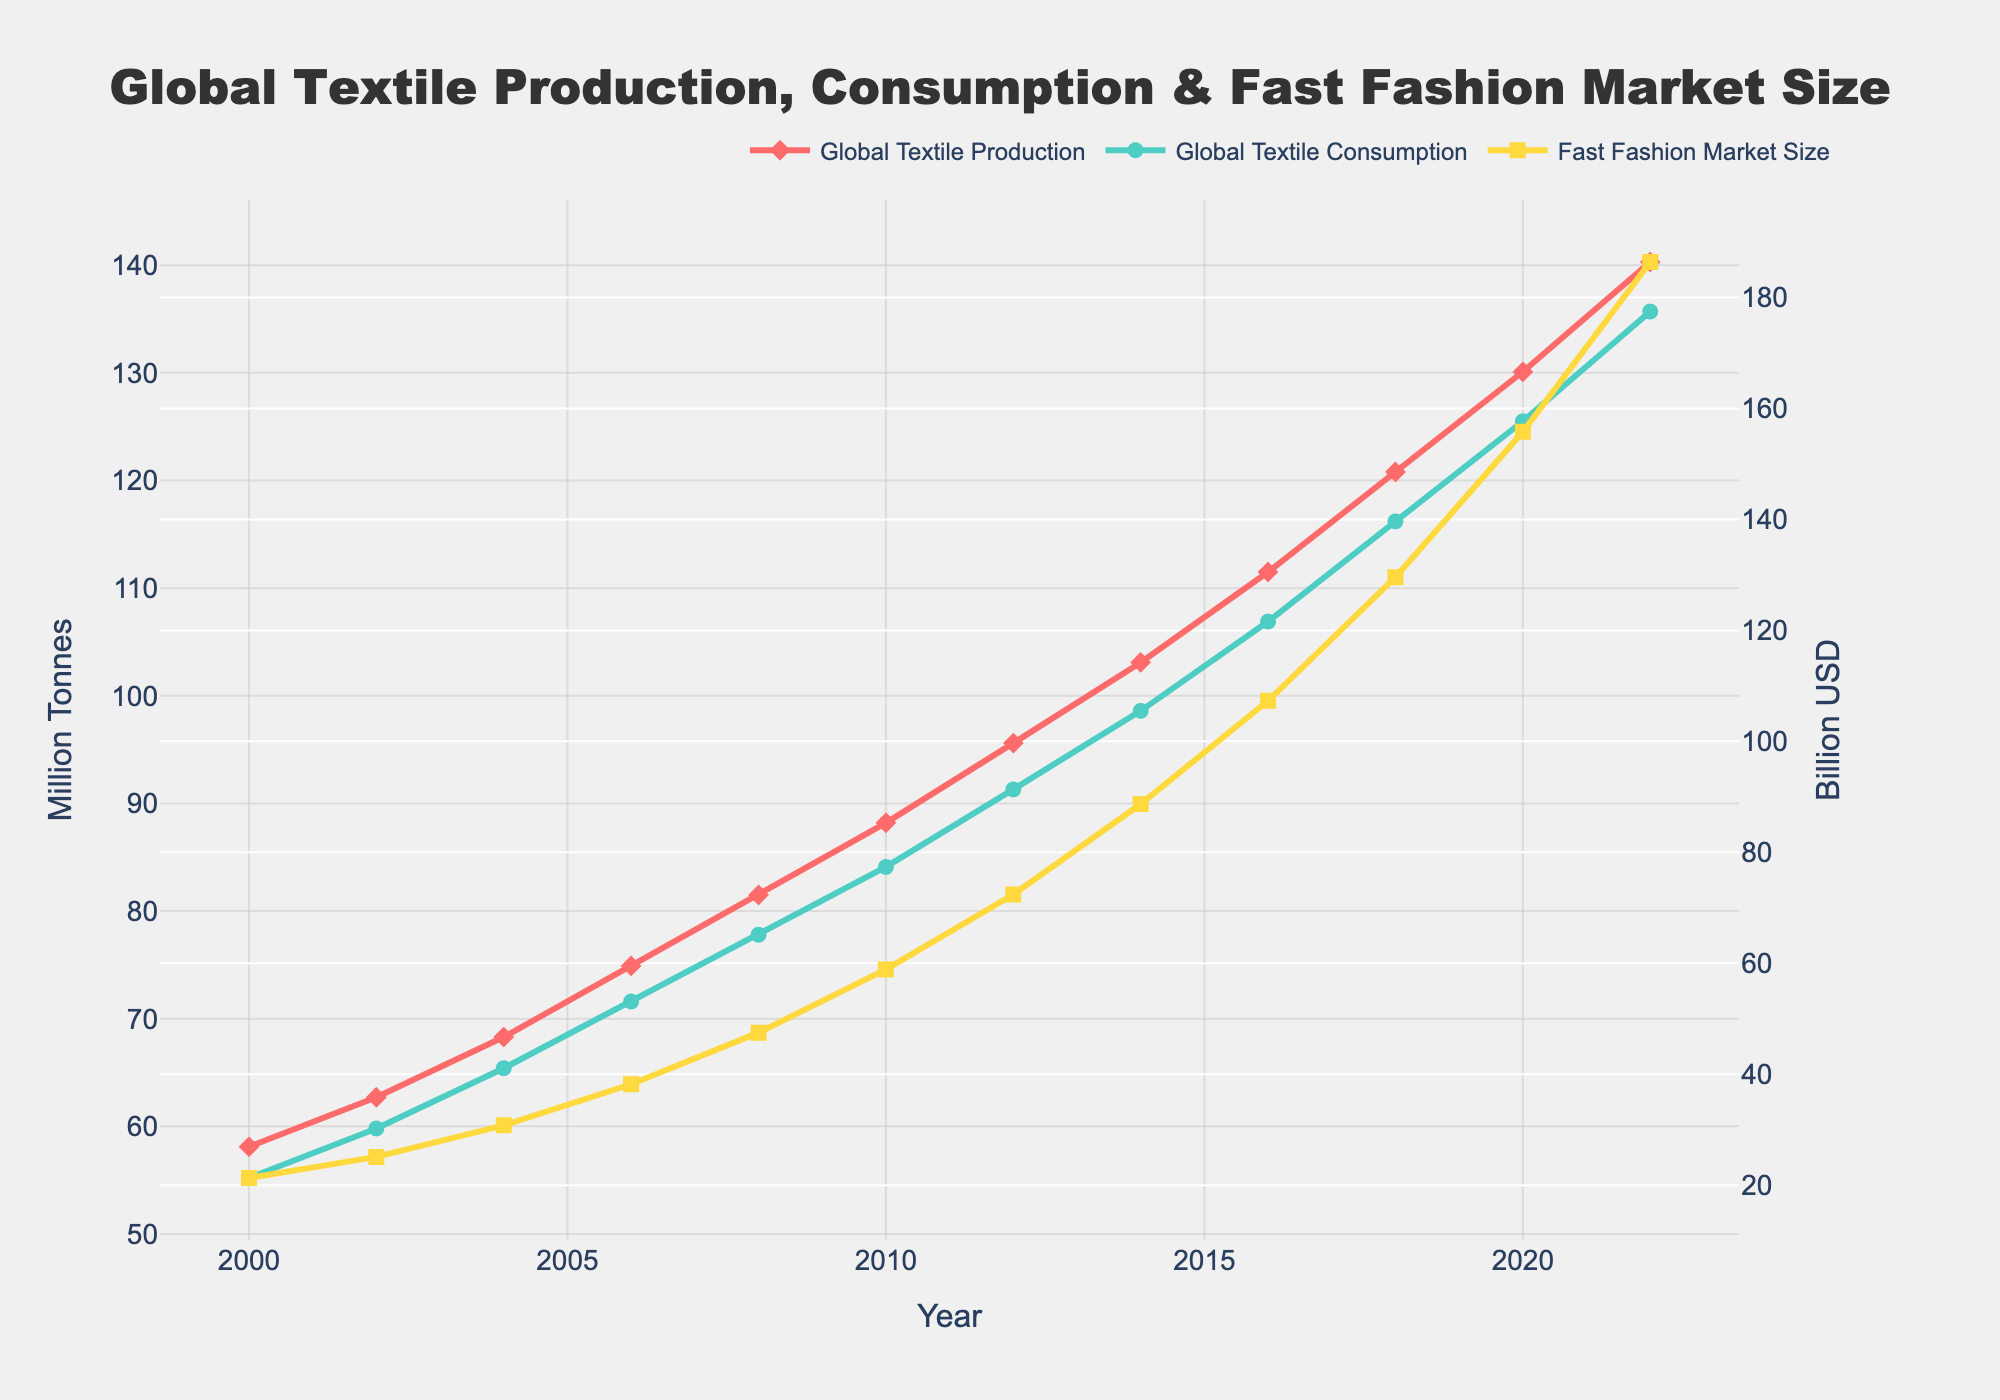What is the difference between global textile production and consumption in 2022? The values for global textile production and consumption in 2022 are 140.3 million tonnes and 135.7 million tonnes, respectively. The difference is calculated as 140.3 - 135.7 = 4.6 million tonnes.
Answer: 4.6 million tonnes Between which years did the Fast Fashion Industry Market Size show the highest growth rate? To find the period with the highest growth rate, we subtract the previous year's market size from the current year's market size and compare the differences. The highest growth increment is between 2020 and 2022, with a market size increase of 186.4 - 155.8 = 30.6 billion USD.
Answer: 2020-2022 Compare the global textile consumption and the Fast Fashion Industry Market Size in the year 2018. Which one was higher? The global textile consumption in 2018 was 116.2 million tonnes, and the Fast Fashion Industry Market Size was 129.6 billion USD. 129.6 billion USD is higher than 116.2 million tonnes.
Answer: Fast Fashion Industry Market Size What colors are used to represent the different measures in the line chart, and which measure does each color represent? The line chart uses three different colors: red represents global textile production, green represents global textile consumption, and yellow represents the Fast Fashion Industry Market Size.
Answer: Red for production, green for consumption, yellow for market size How much did global textile production increase from 2000 to 2022? In 2000, global textile production was 58.1 million tonnes, and in 2022, it was 140.3 million tonnes. The increase is calculated as 140.3 - 58.1 = 82.2 million tonnes.
Answer: 82.2 million tonnes What is the difference between the highest and lowest Fast Fashion Industry Market Size observed in the data? The highest Fast Fashion Industry Market Size is 186.4 billion USD in 2022, and the lowest is 21.3 billion USD in 2000. The difference is 186.4 - 21.3 = 165.1 billion USD.
Answer: 165.1 billion USD Which year saw the global textile consumption reaching 98.6 million tonnes, and what was the Fast Fashion Industry Market Size in that year? The global textile consumption was 98.6 million tonnes in 2014. The Fast Fashion Industry Market Size in that year was 88.7 billion USD.
Answer: 2014, 88.7 billion USD Did global textile production or consumption exceed 100 million tonnes first, and in which year did this occur? Global textile production exceeded 100 million tonnes first in 2014 with 103.1 million tonnes.
Answer: Production, 2014 What is the average global textile production over the years 2000 to 2022? Summing all the production values from 2000 to 2022 (58.1 + 62.7 + 68.3 + 74.9 + 81.5 + 88.2 + 95.6 + 103.1 + 111.5 + 120.8 + 130.1 + 140.3 = 1135.1) and dividing by the number of years (12) yields an average of 1135.1 / 12 = 94.592.
Answer: 94.59 million tonnes How do the trends of global textile production and consumption compare visually? Both global textile production and consumption show an upward trend from 2000 to 2022, but production consistently remains slightly higher than consumption throughout the timeline.
Answer: Production always higher 